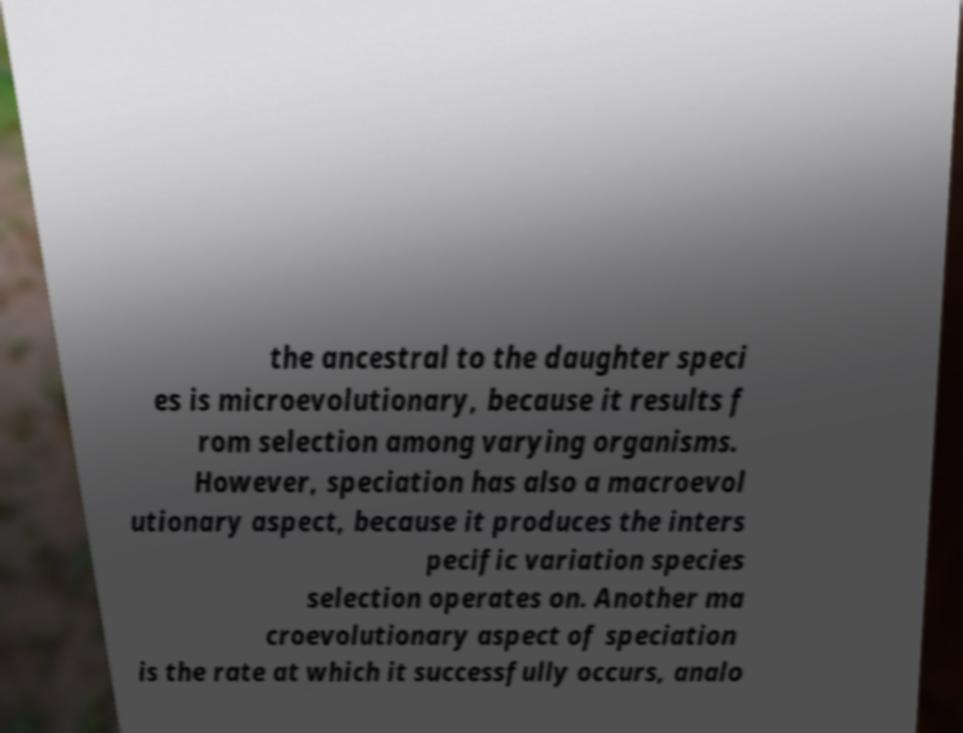What messages or text are displayed in this image? I need them in a readable, typed format. the ancestral to the daughter speci es is microevolutionary, because it results f rom selection among varying organisms. However, speciation has also a macroevol utionary aspect, because it produces the inters pecific variation species selection operates on. Another ma croevolutionary aspect of speciation is the rate at which it successfully occurs, analo 